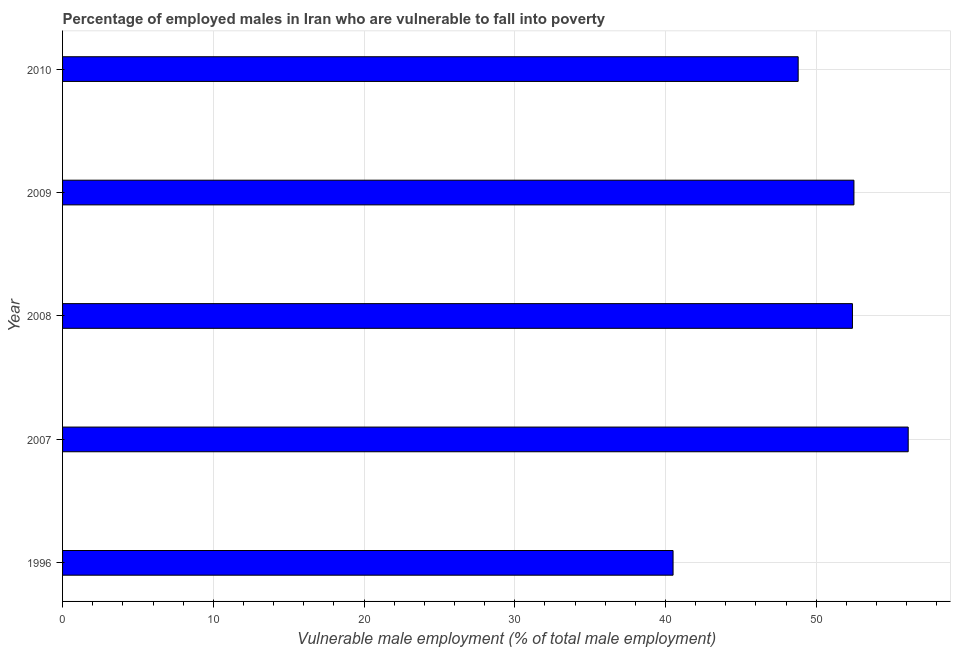Does the graph contain any zero values?
Make the answer very short. No. Does the graph contain grids?
Provide a short and direct response. Yes. What is the title of the graph?
Provide a succinct answer. Percentage of employed males in Iran who are vulnerable to fall into poverty. What is the label or title of the X-axis?
Give a very brief answer. Vulnerable male employment (% of total male employment). What is the percentage of employed males who are vulnerable to fall into poverty in 2007?
Offer a terse response. 56.1. Across all years, what is the maximum percentage of employed males who are vulnerable to fall into poverty?
Give a very brief answer. 56.1. Across all years, what is the minimum percentage of employed males who are vulnerable to fall into poverty?
Make the answer very short. 40.5. In which year was the percentage of employed males who are vulnerable to fall into poverty maximum?
Provide a short and direct response. 2007. In which year was the percentage of employed males who are vulnerable to fall into poverty minimum?
Keep it short and to the point. 1996. What is the sum of the percentage of employed males who are vulnerable to fall into poverty?
Give a very brief answer. 250.3. What is the difference between the percentage of employed males who are vulnerable to fall into poverty in 2007 and 2008?
Offer a terse response. 3.7. What is the average percentage of employed males who are vulnerable to fall into poverty per year?
Your response must be concise. 50.06. What is the median percentage of employed males who are vulnerable to fall into poverty?
Your answer should be compact. 52.4. What is the ratio of the percentage of employed males who are vulnerable to fall into poverty in 2007 to that in 2010?
Your answer should be compact. 1.15. Is the difference between the percentage of employed males who are vulnerable to fall into poverty in 2008 and 2010 greater than the difference between any two years?
Make the answer very short. No. Is the sum of the percentage of employed males who are vulnerable to fall into poverty in 2008 and 2010 greater than the maximum percentage of employed males who are vulnerable to fall into poverty across all years?
Keep it short and to the point. Yes. Are all the bars in the graph horizontal?
Keep it short and to the point. Yes. What is the difference between two consecutive major ticks on the X-axis?
Ensure brevity in your answer.  10. Are the values on the major ticks of X-axis written in scientific E-notation?
Your response must be concise. No. What is the Vulnerable male employment (% of total male employment) of 1996?
Make the answer very short. 40.5. What is the Vulnerable male employment (% of total male employment) in 2007?
Provide a short and direct response. 56.1. What is the Vulnerable male employment (% of total male employment) of 2008?
Ensure brevity in your answer.  52.4. What is the Vulnerable male employment (% of total male employment) in 2009?
Your answer should be very brief. 52.5. What is the Vulnerable male employment (% of total male employment) in 2010?
Your response must be concise. 48.8. What is the difference between the Vulnerable male employment (% of total male employment) in 1996 and 2007?
Provide a short and direct response. -15.6. What is the difference between the Vulnerable male employment (% of total male employment) in 1996 and 2008?
Your answer should be compact. -11.9. What is the difference between the Vulnerable male employment (% of total male employment) in 1996 and 2009?
Your answer should be compact. -12. What is the difference between the Vulnerable male employment (% of total male employment) in 2007 and 2008?
Offer a very short reply. 3.7. What is the difference between the Vulnerable male employment (% of total male employment) in 2008 and 2009?
Your answer should be compact. -0.1. What is the difference between the Vulnerable male employment (% of total male employment) in 2008 and 2010?
Provide a short and direct response. 3.6. What is the ratio of the Vulnerable male employment (% of total male employment) in 1996 to that in 2007?
Give a very brief answer. 0.72. What is the ratio of the Vulnerable male employment (% of total male employment) in 1996 to that in 2008?
Keep it short and to the point. 0.77. What is the ratio of the Vulnerable male employment (% of total male employment) in 1996 to that in 2009?
Your response must be concise. 0.77. What is the ratio of the Vulnerable male employment (% of total male employment) in 1996 to that in 2010?
Ensure brevity in your answer.  0.83. What is the ratio of the Vulnerable male employment (% of total male employment) in 2007 to that in 2008?
Keep it short and to the point. 1.07. What is the ratio of the Vulnerable male employment (% of total male employment) in 2007 to that in 2009?
Your answer should be compact. 1.07. What is the ratio of the Vulnerable male employment (% of total male employment) in 2007 to that in 2010?
Provide a succinct answer. 1.15. What is the ratio of the Vulnerable male employment (% of total male employment) in 2008 to that in 2010?
Ensure brevity in your answer.  1.07. What is the ratio of the Vulnerable male employment (% of total male employment) in 2009 to that in 2010?
Your answer should be very brief. 1.08. 